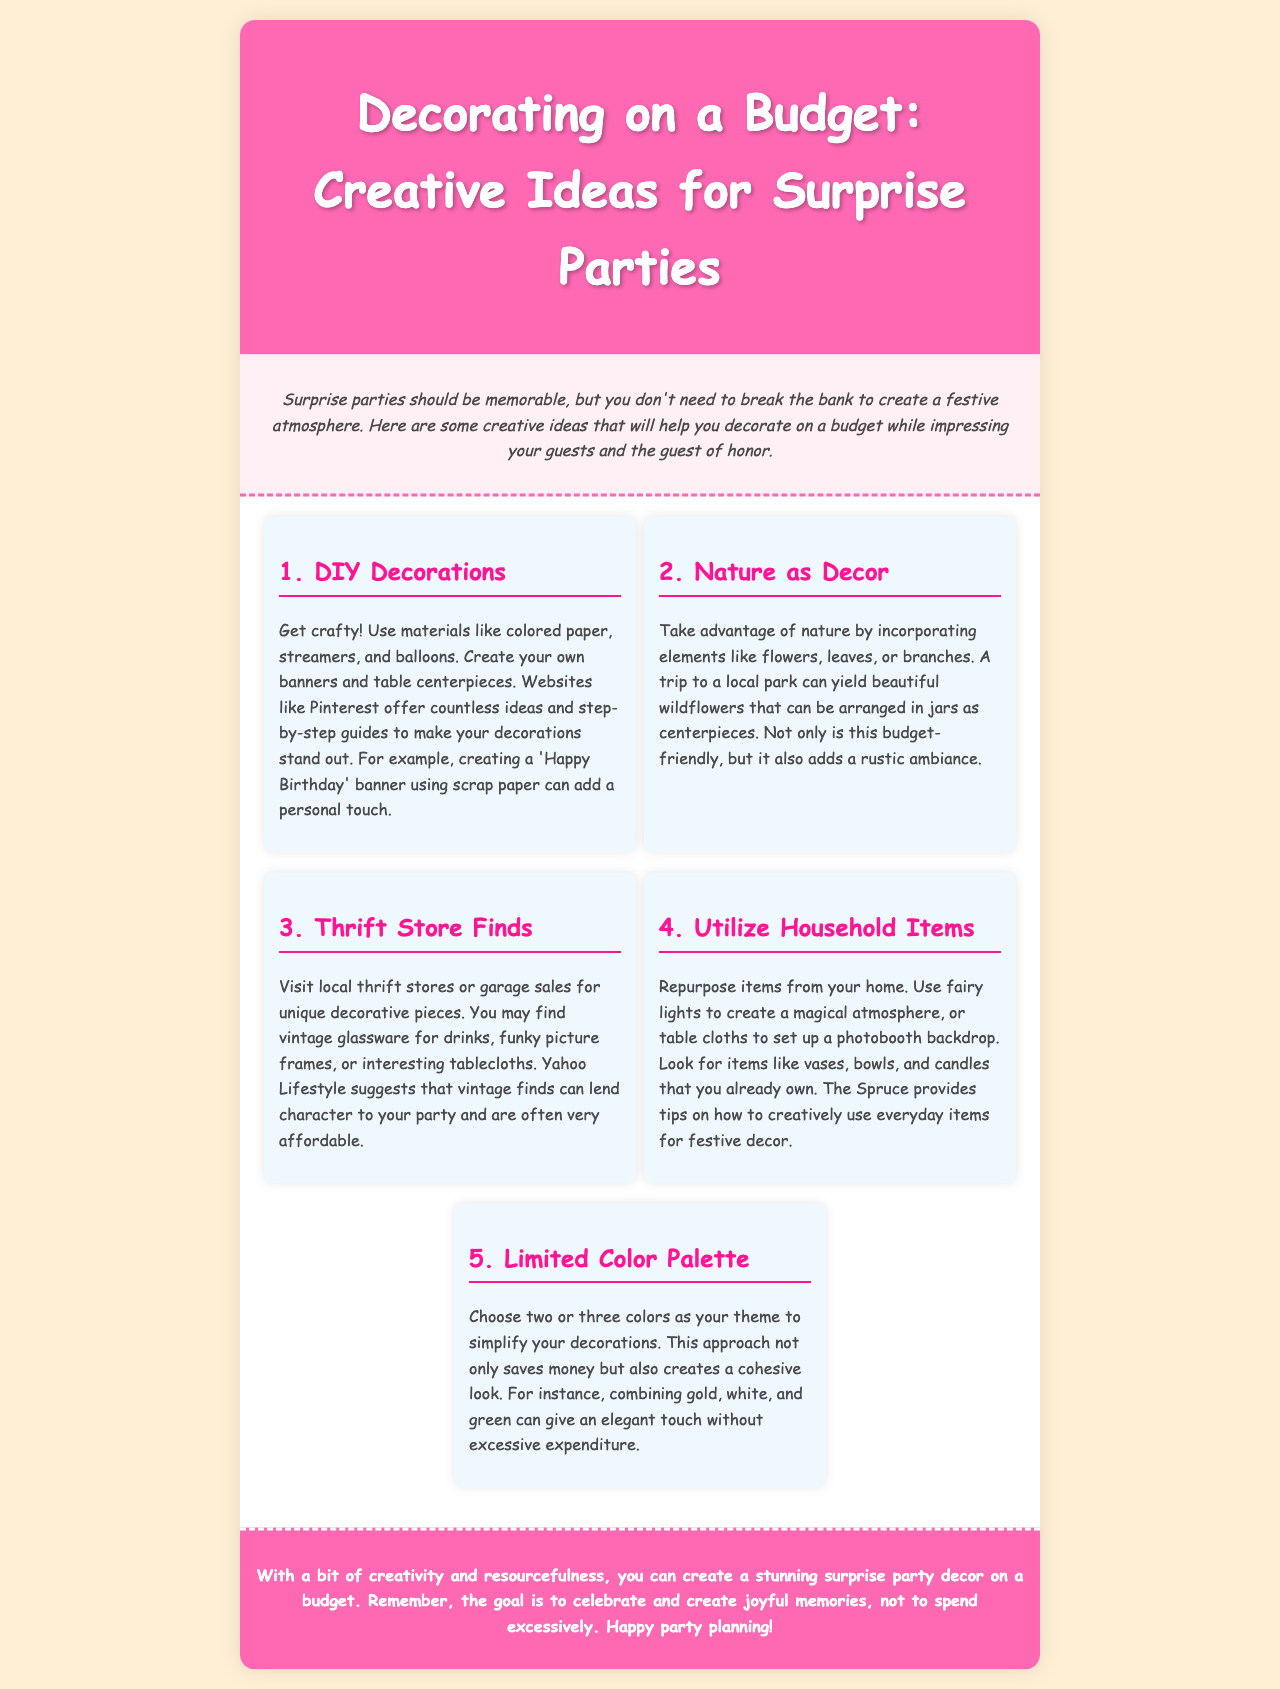What is the title of the brochure? The title is prominently displayed at the top of the document, indicating the main topic.
Answer: Decorating on a Budget: Creative Ideas for Surprise Parties What is one type of decoration you can create yourself? The brochure lists various DIY options where you can get crafty, specifically mentioning materials and examples.
Answer: Banners What natural element can be used as decor? The document suggests using natural elements for decoration, highlighting a specific example.
Answer: Flowers Which color palette approach is recommended? The brochure mentions a method to simplify decorations that involves choosing specific colors.
Answer: Limited Color Palette How many sections are there in the content? The document lists five distinct sections that provide various creative ideas for decorations.
Answer: Five What is one source mentioned for DIY decoration ideas? The brochure references specific websites that offer guides and inspiration for DIY projects.
Answer: Pinterest Which item can be repurposed from home for decor? The brochure suggests using common household items creatively for party decorations.
Answer: Fairy lights What is the goal of the surprise party according to the conclusion? The conclusion summarizes the primary motivation behind organizing a surprise party.
Answer: Celebrate What style is the font used in the brochure? The design of the brochure indicates a playful and informal approach to the font choice.
Answer: Comic Sans MS 